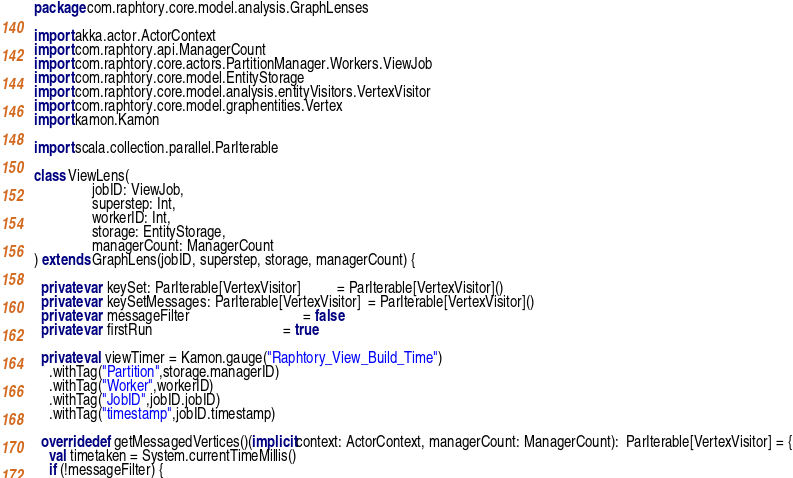Convert code to text. <code><loc_0><loc_0><loc_500><loc_500><_Scala_>package com.raphtory.core.model.analysis.GraphLenses

import akka.actor.ActorContext
import com.raphtory.api.ManagerCount
import com.raphtory.core.actors.PartitionManager.Workers.ViewJob
import com.raphtory.core.model.EntityStorage
import com.raphtory.core.model.analysis.entityVisitors.VertexVisitor
import com.raphtory.core.model.graphentities.Vertex
import kamon.Kamon

import scala.collection.parallel.ParIterable

class ViewLens(
                jobID: ViewJob,
                superstep: Int,
                workerID: Int,
                storage: EntityStorage,
                managerCount: ManagerCount
) extends GraphLens(jobID, superstep, storage, managerCount) {

  private var keySet: ParIterable[VertexVisitor]          = ParIterable[VertexVisitor]()
  private var keySetMessages: ParIterable[VertexVisitor]  = ParIterable[VertexVisitor]()
  private var messageFilter                               = false
  private var firstRun                                    = true

  private val viewTimer = Kamon.gauge("Raphtory_View_Build_Time")
    .withTag("Partition",storage.managerID)
    .withTag("Worker",workerID)
    .withTag("JobID",jobID.jobID)
    .withTag("timestamp",jobID.timestamp)

  override def getMessagedVertices()(implicit context: ActorContext, managerCount: ManagerCount):  ParIterable[VertexVisitor] = {
    val timetaken = System.currentTimeMillis()
    if (!messageFilter) {</code> 